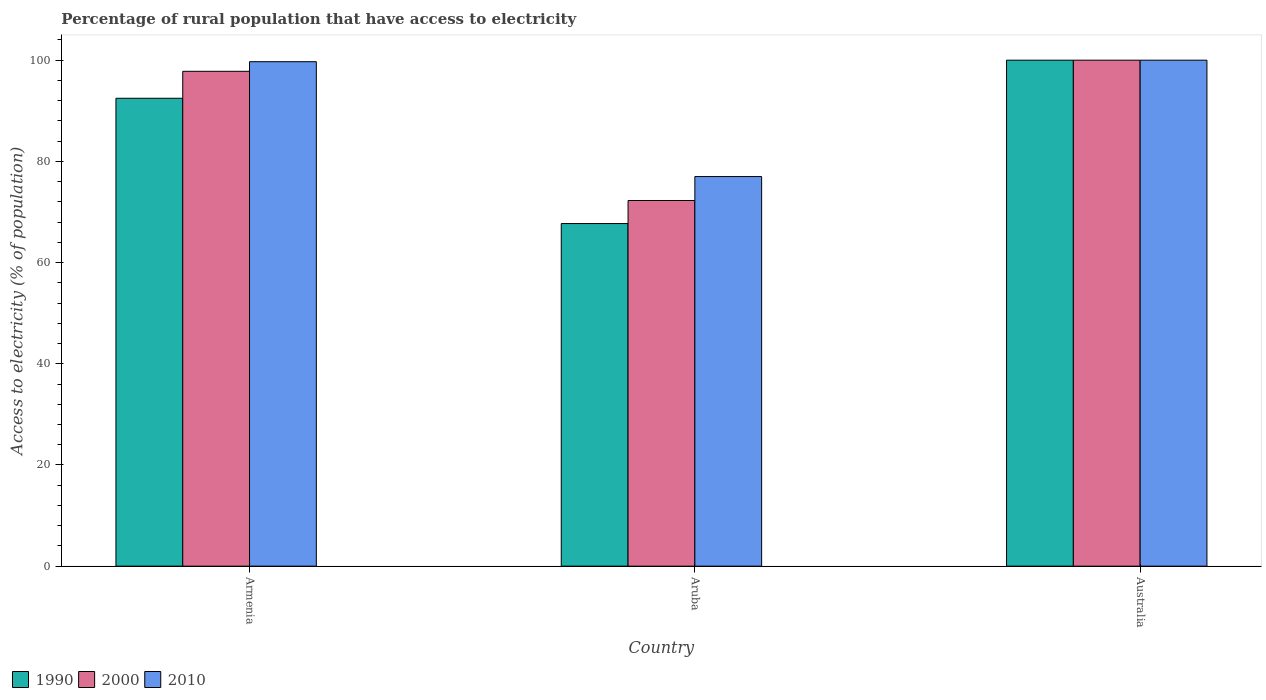How many different coloured bars are there?
Your answer should be compact. 3. How many groups of bars are there?
Your response must be concise. 3. How many bars are there on the 2nd tick from the left?
Provide a succinct answer. 3. What is the label of the 2nd group of bars from the left?
Your response must be concise. Aruba. What is the percentage of rural population that have access to electricity in 1990 in Australia?
Make the answer very short. 100. Across all countries, what is the maximum percentage of rural population that have access to electricity in 2010?
Offer a terse response. 100. Across all countries, what is the minimum percentage of rural population that have access to electricity in 2000?
Provide a succinct answer. 72.27. In which country was the percentage of rural population that have access to electricity in 2010 minimum?
Give a very brief answer. Aruba. What is the total percentage of rural population that have access to electricity in 2000 in the graph?
Offer a terse response. 270.07. What is the difference between the percentage of rural population that have access to electricity in 2000 in Aruba and that in Australia?
Keep it short and to the point. -27.73. What is the difference between the percentage of rural population that have access to electricity in 2000 in Australia and the percentage of rural population that have access to electricity in 1990 in Aruba?
Keep it short and to the point. 32.29. What is the average percentage of rural population that have access to electricity in 2000 per country?
Offer a terse response. 90.02. What is the difference between the percentage of rural population that have access to electricity of/in 2000 and percentage of rural population that have access to electricity of/in 1990 in Armenia?
Your answer should be very brief. 5.33. What is the ratio of the percentage of rural population that have access to electricity in 2010 in Aruba to that in Australia?
Your answer should be compact. 0.77. Is the percentage of rural population that have access to electricity in 2010 in Armenia less than that in Aruba?
Offer a very short reply. No. What is the difference between the highest and the second highest percentage of rural population that have access to electricity in 2000?
Offer a terse response. -25.53. What is the difference between the highest and the lowest percentage of rural population that have access to electricity in 1990?
Your answer should be compact. 32.29. Is the sum of the percentage of rural population that have access to electricity in 2000 in Aruba and Australia greater than the maximum percentage of rural population that have access to electricity in 1990 across all countries?
Make the answer very short. Yes. What does the 1st bar from the left in Australia represents?
Your response must be concise. 1990. How many bars are there?
Provide a succinct answer. 9. Are all the bars in the graph horizontal?
Your answer should be very brief. No. Does the graph contain any zero values?
Offer a very short reply. No. How many legend labels are there?
Make the answer very short. 3. What is the title of the graph?
Provide a succinct answer. Percentage of rural population that have access to electricity. Does "1965" appear as one of the legend labels in the graph?
Your answer should be compact. No. What is the label or title of the X-axis?
Keep it short and to the point. Country. What is the label or title of the Y-axis?
Offer a terse response. Access to electricity (% of population). What is the Access to electricity (% of population) of 1990 in Armenia?
Provide a succinct answer. 92.47. What is the Access to electricity (% of population) of 2000 in Armenia?
Keep it short and to the point. 97.8. What is the Access to electricity (% of population) of 2010 in Armenia?
Offer a terse response. 99.7. What is the Access to electricity (% of population) in 1990 in Aruba?
Provide a succinct answer. 67.71. What is the Access to electricity (% of population) in 2000 in Aruba?
Your response must be concise. 72.27. What is the Access to electricity (% of population) in 2010 in Aruba?
Offer a very short reply. 77. What is the Access to electricity (% of population) of 1990 in Australia?
Provide a short and direct response. 100. What is the Access to electricity (% of population) in 2010 in Australia?
Your response must be concise. 100. Across all countries, what is the maximum Access to electricity (% of population) in 1990?
Ensure brevity in your answer.  100. Across all countries, what is the maximum Access to electricity (% of population) in 2000?
Provide a succinct answer. 100. Across all countries, what is the maximum Access to electricity (% of population) of 2010?
Provide a succinct answer. 100. Across all countries, what is the minimum Access to electricity (% of population) of 1990?
Your response must be concise. 67.71. Across all countries, what is the minimum Access to electricity (% of population) of 2000?
Provide a short and direct response. 72.27. What is the total Access to electricity (% of population) of 1990 in the graph?
Provide a succinct answer. 260.18. What is the total Access to electricity (% of population) of 2000 in the graph?
Make the answer very short. 270.06. What is the total Access to electricity (% of population) of 2010 in the graph?
Your answer should be very brief. 276.7. What is the difference between the Access to electricity (% of population) of 1990 in Armenia and that in Aruba?
Your response must be concise. 24.76. What is the difference between the Access to electricity (% of population) of 2000 in Armenia and that in Aruba?
Give a very brief answer. 25.54. What is the difference between the Access to electricity (% of population) in 2010 in Armenia and that in Aruba?
Keep it short and to the point. 22.7. What is the difference between the Access to electricity (% of population) of 1990 in Armenia and that in Australia?
Give a very brief answer. -7.53. What is the difference between the Access to electricity (% of population) in 2000 in Armenia and that in Australia?
Provide a short and direct response. -2.2. What is the difference between the Access to electricity (% of population) in 1990 in Aruba and that in Australia?
Ensure brevity in your answer.  -32.29. What is the difference between the Access to electricity (% of population) in 2000 in Aruba and that in Australia?
Provide a succinct answer. -27.73. What is the difference between the Access to electricity (% of population) in 2010 in Aruba and that in Australia?
Offer a very short reply. -23. What is the difference between the Access to electricity (% of population) of 1990 in Armenia and the Access to electricity (% of population) of 2000 in Aruba?
Provide a short and direct response. 20.2. What is the difference between the Access to electricity (% of population) of 1990 in Armenia and the Access to electricity (% of population) of 2010 in Aruba?
Your response must be concise. 15.47. What is the difference between the Access to electricity (% of population) of 2000 in Armenia and the Access to electricity (% of population) of 2010 in Aruba?
Provide a short and direct response. 20.8. What is the difference between the Access to electricity (% of population) in 1990 in Armenia and the Access to electricity (% of population) in 2000 in Australia?
Make the answer very short. -7.53. What is the difference between the Access to electricity (% of population) in 1990 in Armenia and the Access to electricity (% of population) in 2010 in Australia?
Your response must be concise. -7.53. What is the difference between the Access to electricity (% of population) in 2000 in Armenia and the Access to electricity (% of population) in 2010 in Australia?
Your answer should be compact. -2.2. What is the difference between the Access to electricity (% of population) in 1990 in Aruba and the Access to electricity (% of population) in 2000 in Australia?
Offer a terse response. -32.29. What is the difference between the Access to electricity (% of population) in 1990 in Aruba and the Access to electricity (% of population) in 2010 in Australia?
Ensure brevity in your answer.  -32.29. What is the difference between the Access to electricity (% of population) in 2000 in Aruba and the Access to electricity (% of population) in 2010 in Australia?
Make the answer very short. -27.73. What is the average Access to electricity (% of population) of 1990 per country?
Provide a short and direct response. 86.73. What is the average Access to electricity (% of population) in 2000 per country?
Keep it short and to the point. 90.02. What is the average Access to electricity (% of population) in 2010 per country?
Provide a succinct answer. 92.23. What is the difference between the Access to electricity (% of population) of 1990 and Access to electricity (% of population) of 2000 in Armenia?
Provide a succinct answer. -5.33. What is the difference between the Access to electricity (% of population) of 1990 and Access to electricity (% of population) of 2010 in Armenia?
Ensure brevity in your answer.  -7.23. What is the difference between the Access to electricity (% of population) of 1990 and Access to electricity (% of population) of 2000 in Aruba?
Your answer should be compact. -4.55. What is the difference between the Access to electricity (% of population) in 1990 and Access to electricity (% of population) in 2010 in Aruba?
Your answer should be very brief. -9.29. What is the difference between the Access to electricity (% of population) of 2000 and Access to electricity (% of population) of 2010 in Aruba?
Your response must be concise. -4.74. What is the difference between the Access to electricity (% of population) in 1990 and Access to electricity (% of population) in 2000 in Australia?
Provide a short and direct response. 0. What is the difference between the Access to electricity (% of population) in 1990 and Access to electricity (% of population) in 2010 in Australia?
Your response must be concise. 0. What is the ratio of the Access to electricity (% of population) in 1990 in Armenia to that in Aruba?
Provide a succinct answer. 1.37. What is the ratio of the Access to electricity (% of population) of 2000 in Armenia to that in Aruba?
Provide a succinct answer. 1.35. What is the ratio of the Access to electricity (% of population) of 2010 in Armenia to that in Aruba?
Your answer should be compact. 1.29. What is the ratio of the Access to electricity (% of population) of 1990 in Armenia to that in Australia?
Offer a terse response. 0.92. What is the ratio of the Access to electricity (% of population) of 2000 in Armenia to that in Australia?
Offer a very short reply. 0.98. What is the ratio of the Access to electricity (% of population) in 1990 in Aruba to that in Australia?
Provide a succinct answer. 0.68. What is the ratio of the Access to electricity (% of population) in 2000 in Aruba to that in Australia?
Provide a short and direct response. 0.72. What is the ratio of the Access to electricity (% of population) of 2010 in Aruba to that in Australia?
Your answer should be very brief. 0.77. What is the difference between the highest and the second highest Access to electricity (% of population) in 1990?
Offer a very short reply. 7.53. What is the difference between the highest and the lowest Access to electricity (% of population) of 1990?
Give a very brief answer. 32.29. What is the difference between the highest and the lowest Access to electricity (% of population) of 2000?
Make the answer very short. 27.73. 